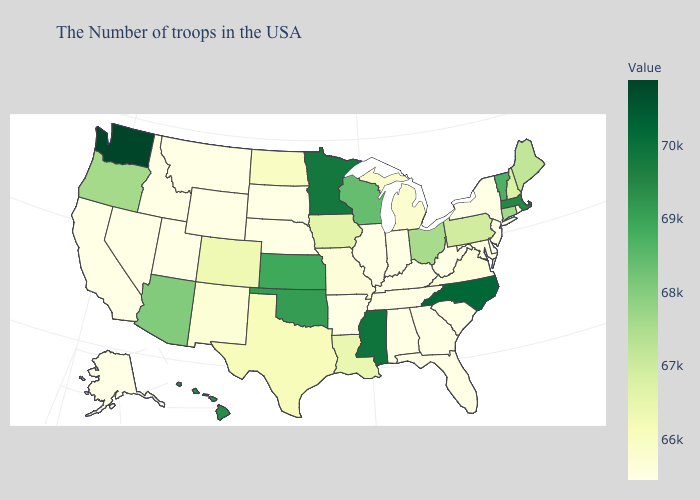Which states have the lowest value in the MidWest?
Be succinct. Indiana, Illinois, Nebraska, South Dakota. Does Pennsylvania have the lowest value in the Northeast?
Short answer required. No. Which states have the lowest value in the USA?
Concise answer only. Rhode Island, New York, New Jersey, Delaware, South Carolina, West Virginia, Florida, Georgia, Kentucky, Indiana, Alabama, Tennessee, Illinois, Arkansas, Nebraska, South Dakota, Wyoming, Utah, Montana, Idaho, Nevada, California, Alaska. Does Massachusetts have a higher value than Washington?
Answer briefly. No. Among the states that border California , does Arizona have the highest value?
Keep it brief. Yes. Which states have the highest value in the USA?
Give a very brief answer. Washington. 